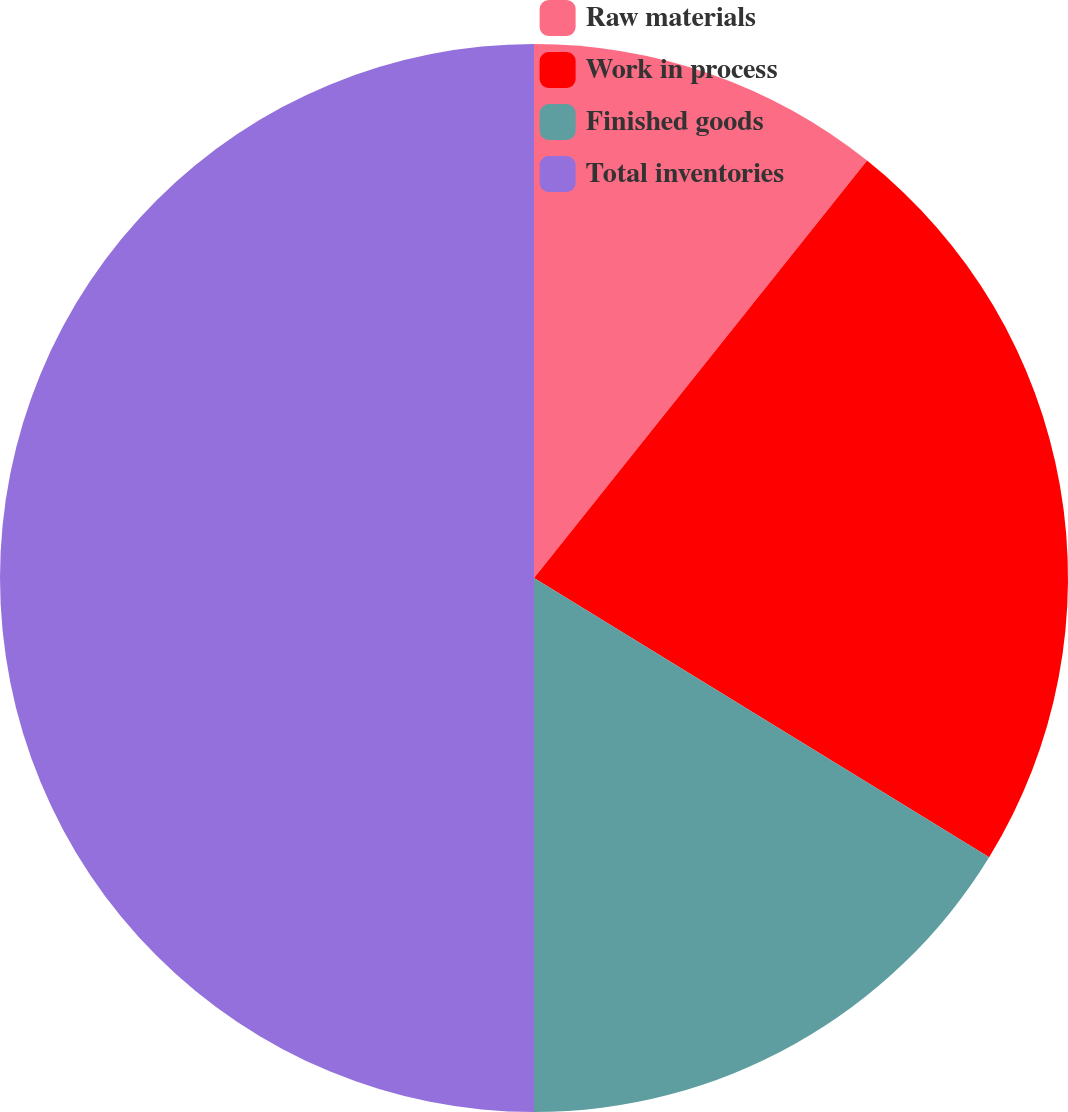<chart> <loc_0><loc_0><loc_500><loc_500><pie_chart><fcel>Raw materials<fcel>Work in process<fcel>Finished goods<fcel>Total inventories<nl><fcel>10.72%<fcel>23.04%<fcel>16.24%<fcel>50.0%<nl></chart> 